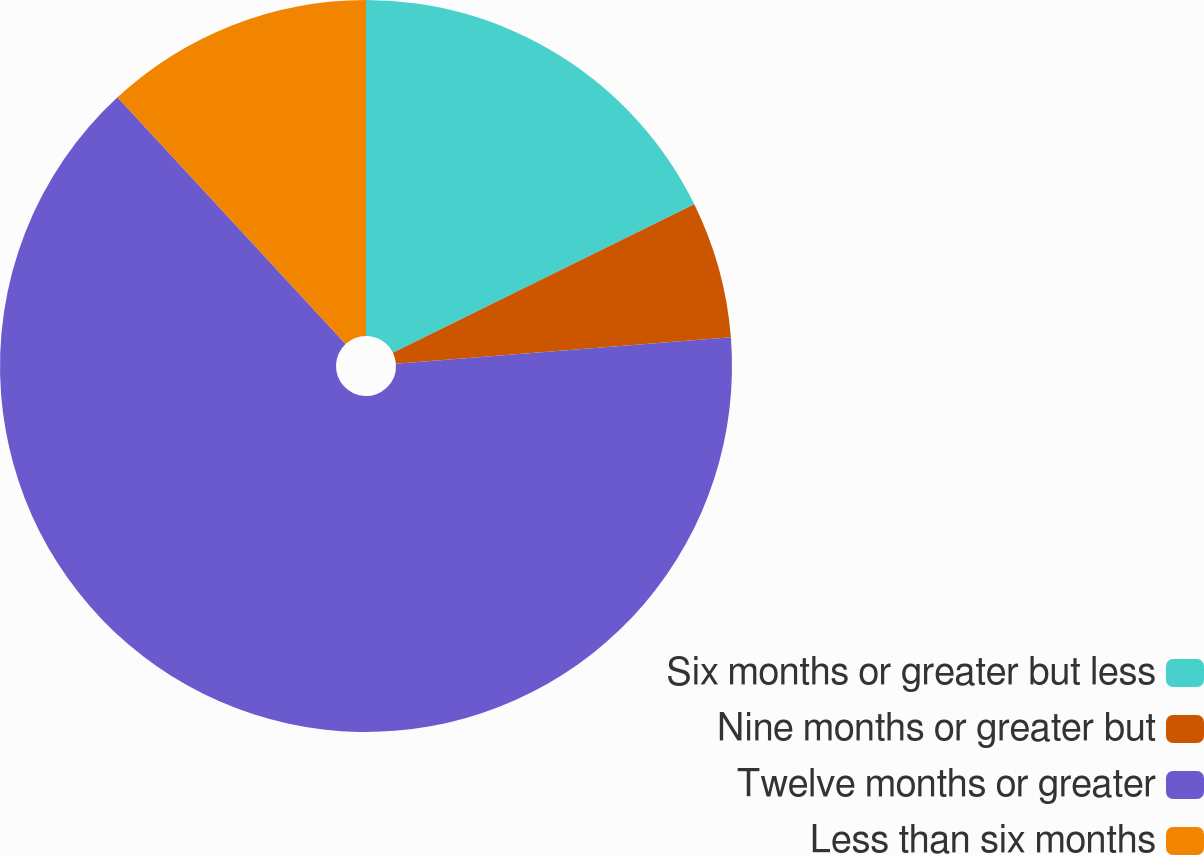Convert chart. <chart><loc_0><loc_0><loc_500><loc_500><pie_chart><fcel>Six months or greater but less<fcel>Nine months or greater but<fcel>Twelve months or greater<fcel>Less than six months<nl><fcel>17.71%<fcel>6.04%<fcel>64.37%<fcel>11.88%<nl></chart> 